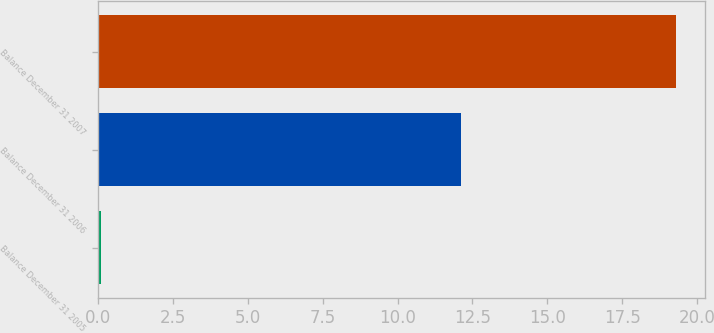Convert chart. <chart><loc_0><loc_0><loc_500><loc_500><bar_chart><fcel>Balance December 31 2005<fcel>Balance December 31 2006<fcel>Balance December 31 2007<nl><fcel>0.1<fcel>12.1<fcel>19.3<nl></chart> 